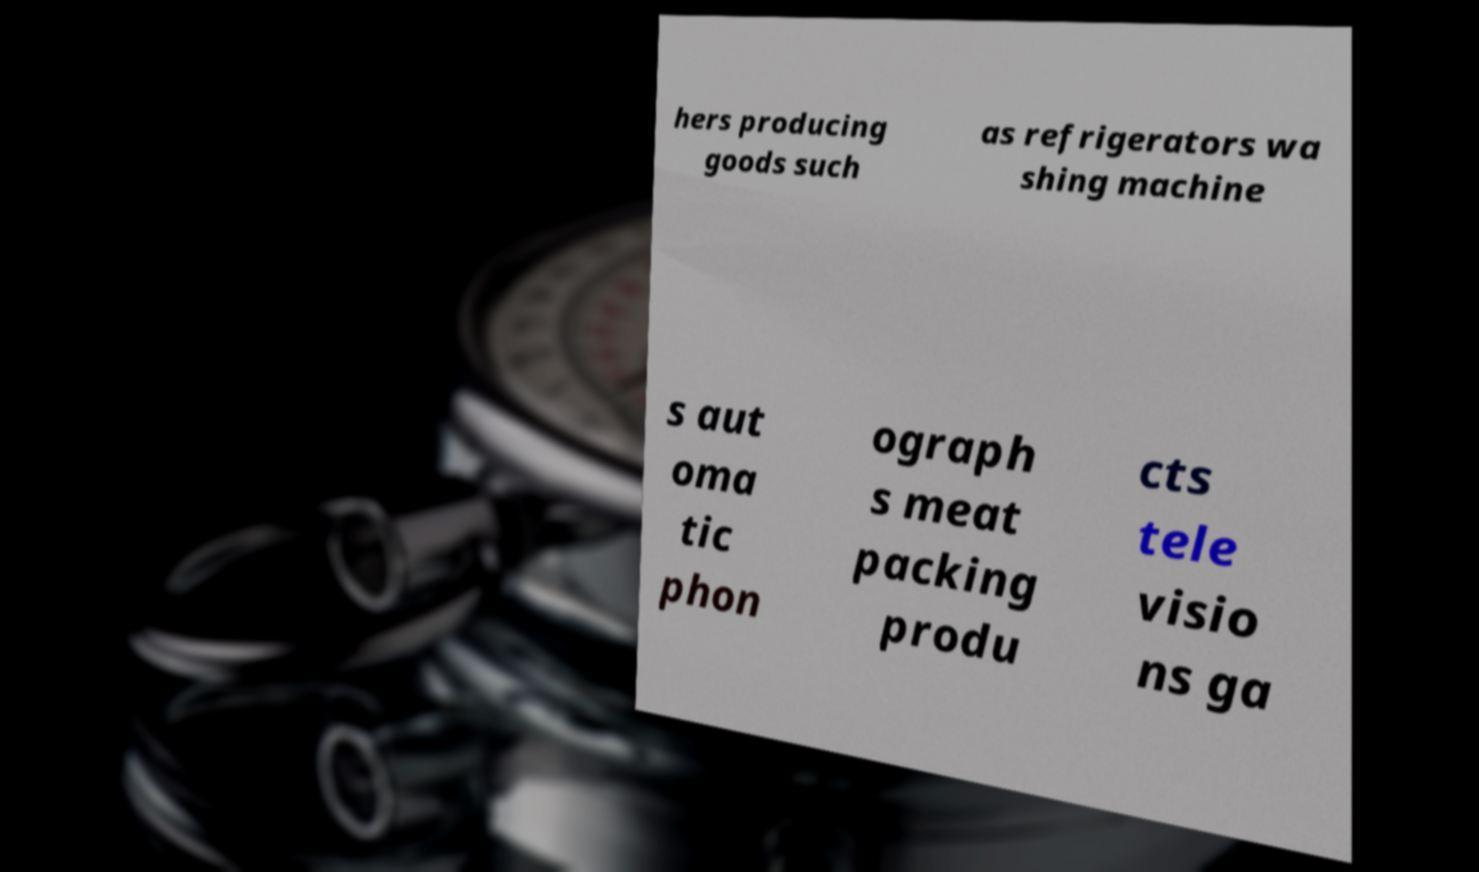Please identify and transcribe the text found in this image. hers producing goods such as refrigerators wa shing machine s aut oma tic phon ograph s meat packing produ cts tele visio ns ga 